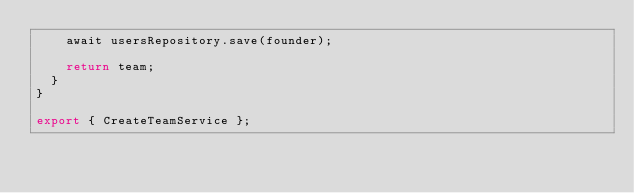<code> <loc_0><loc_0><loc_500><loc_500><_TypeScript_>    await usersRepository.save(founder);

    return team;
  }
}

export { CreateTeamService };
</code> 